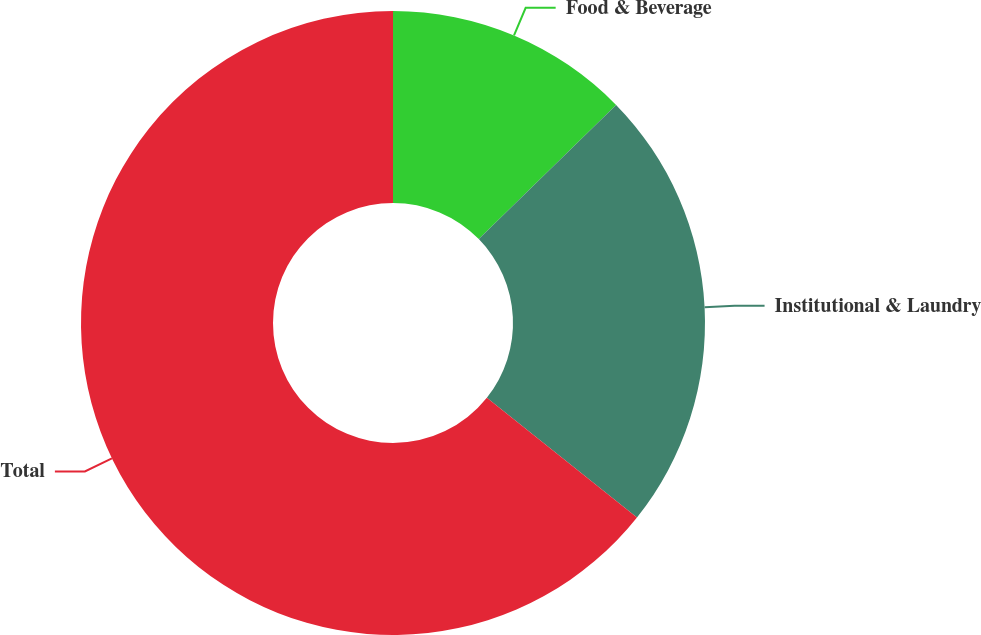Convert chart to OTSL. <chart><loc_0><loc_0><loc_500><loc_500><pie_chart><fcel>Food & Beverage<fcel>Institutional & Laundry<fcel>Total<nl><fcel>12.68%<fcel>23.03%<fcel>64.29%<nl></chart> 